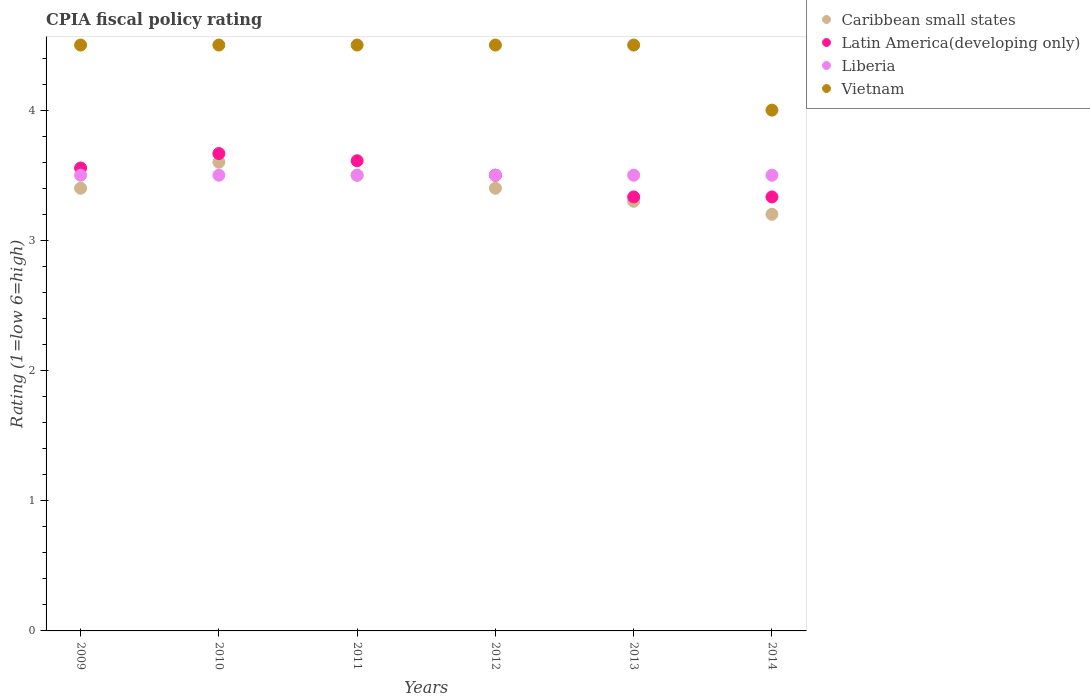What is the CPIA rating in Latin America(developing only) in 2011?
Provide a short and direct response. 3.61. Across all years, what is the maximum CPIA rating in Latin America(developing only)?
Make the answer very short. 3.67. Across all years, what is the minimum CPIA rating in Latin America(developing only)?
Ensure brevity in your answer.  3.33. What is the total CPIA rating in Latin America(developing only) in the graph?
Your answer should be compact. 21. What is the difference between the CPIA rating in Latin America(developing only) in 2009 and that in 2011?
Your response must be concise. -0.06. What is the difference between the CPIA rating in Caribbean small states in 2013 and the CPIA rating in Liberia in 2014?
Offer a very short reply. -0.2. What is the average CPIA rating in Vietnam per year?
Ensure brevity in your answer.  4.42. In the year 2012, what is the difference between the CPIA rating in Caribbean small states and CPIA rating in Liberia?
Make the answer very short. -0.1. In how many years, is the CPIA rating in Vietnam greater than 0.6000000000000001?
Offer a very short reply. 6. What is the difference between the highest and the second highest CPIA rating in Caribbean small states?
Make the answer very short. 0.1. In how many years, is the CPIA rating in Latin America(developing only) greater than the average CPIA rating in Latin America(developing only) taken over all years?
Offer a terse response. 4. Is the sum of the CPIA rating in Latin America(developing only) in 2011 and 2013 greater than the maximum CPIA rating in Liberia across all years?
Make the answer very short. Yes. Is it the case that in every year, the sum of the CPIA rating in Latin America(developing only) and CPIA rating in Liberia  is greater than the CPIA rating in Caribbean small states?
Offer a terse response. Yes. Is the CPIA rating in Caribbean small states strictly less than the CPIA rating in Liberia over the years?
Ensure brevity in your answer.  No. How many years are there in the graph?
Your answer should be very brief. 6. Are the values on the major ticks of Y-axis written in scientific E-notation?
Provide a succinct answer. No. Does the graph contain any zero values?
Keep it short and to the point. No. Does the graph contain grids?
Your answer should be compact. No. Where does the legend appear in the graph?
Make the answer very short. Top right. How many legend labels are there?
Your answer should be compact. 4. What is the title of the graph?
Your answer should be compact. CPIA fiscal policy rating. What is the Rating (1=low 6=high) of Latin America(developing only) in 2009?
Your answer should be very brief. 3.56. What is the Rating (1=low 6=high) in Latin America(developing only) in 2010?
Offer a very short reply. 3.67. What is the Rating (1=low 6=high) in Liberia in 2010?
Offer a very short reply. 3.5. What is the Rating (1=low 6=high) in Vietnam in 2010?
Your answer should be very brief. 4.5. What is the Rating (1=low 6=high) of Caribbean small states in 2011?
Provide a short and direct response. 3.5. What is the Rating (1=low 6=high) of Latin America(developing only) in 2011?
Make the answer very short. 3.61. What is the Rating (1=low 6=high) in Caribbean small states in 2012?
Provide a short and direct response. 3.4. What is the Rating (1=low 6=high) in Latin America(developing only) in 2012?
Provide a succinct answer. 3.5. What is the Rating (1=low 6=high) of Vietnam in 2012?
Offer a very short reply. 4.5. What is the Rating (1=low 6=high) of Caribbean small states in 2013?
Make the answer very short. 3.3. What is the Rating (1=low 6=high) in Latin America(developing only) in 2013?
Provide a succinct answer. 3.33. What is the Rating (1=low 6=high) of Vietnam in 2013?
Your answer should be compact. 4.5. What is the Rating (1=low 6=high) of Latin America(developing only) in 2014?
Keep it short and to the point. 3.33. What is the Rating (1=low 6=high) of Vietnam in 2014?
Ensure brevity in your answer.  4. Across all years, what is the maximum Rating (1=low 6=high) in Caribbean small states?
Offer a very short reply. 3.6. Across all years, what is the maximum Rating (1=low 6=high) of Latin America(developing only)?
Offer a terse response. 3.67. Across all years, what is the minimum Rating (1=low 6=high) of Caribbean small states?
Give a very brief answer. 3.2. Across all years, what is the minimum Rating (1=low 6=high) in Latin America(developing only)?
Provide a short and direct response. 3.33. What is the total Rating (1=low 6=high) in Caribbean small states in the graph?
Give a very brief answer. 20.4. What is the total Rating (1=low 6=high) in Latin America(developing only) in the graph?
Provide a short and direct response. 21. What is the total Rating (1=low 6=high) in Liberia in the graph?
Provide a short and direct response. 21. What is the total Rating (1=low 6=high) of Vietnam in the graph?
Make the answer very short. 26.5. What is the difference between the Rating (1=low 6=high) of Caribbean small states in 2009 and that in 2010?
Give a very brief answer. -0.2. What is the difference between the Rating (1=low 6=high) of Latin America(developing only) in 2009 and that in 2010?
Offer a very short reply. -0.11. What is the difference between the Rating (1=low 6=high) in Liberia in 2009 and that in 2010?
Your answer should be very brief. 0. What is the difference between the Rating (1=low 6=high) of Latin America(developing only) in 2009 and that in 2011?
Offer a terse response. -0.06. What is the difference between the Rating (1=low 6=high) in Latin America(developing only) in 2009 and that in 2012?
Your answer should be very brief. 0.06. What is the difference between the Rating (1=low 6=high) in Vietnam in 2009 and that in 2012?
Your response must be concise. 0. What is the difference between the Rating (1=low 6=high) of Caribbean small states in 2009 and that in 2013?
Offer a very short reply. 0.1. What is the difference between the Rating (1=low 6=high) in Latin America(developing only) in 2009 and that in 2013?
Offer a very short reply. 0.22. What is the difference between the Rating (1=low 6=high) in Caribbean small states in 2009 and that in 2014?
Offer a very short reply. 0.2. What is the difference between the Rating (1=low 6=high) in Latin America(developing only) in 2009 and that in 2014?
Keep it short and to the point. 0.22. What is the difference between the Rating (1=low 6=high) in Vietnam in 2009 and that in 2014?
Ensure brevity in your answer.  0.5. What is the difference between the Rating (1=low 6=high) in Latin America(developing only) in 2010 and that in 2011?
Your answer should be compact. 0.06. What is the difference between the Rating (1=low 6=high) in Liberia in 2010 and that in 2011?
Provide a short and direct response. 0. What is the difference between the Rating (1=low 6=high) of Caribbean small states in 2010 and that in 2012?
Keep it short and to the point. 0.2. What is the difference between the Rating (1=low 6=high) in Vietnam in 2010 and that in 2012?
Offer a terse response. 0. What is the difference between the Rating (1=low 6=high) in Latin America(developing only) in 2010 and that in 2013?
Provide a succinct answer. 0.33. What is the difference between the Rating (1=low 6=high) in Liberia in 2010 and that in 2013?
Give a very brief answer. 0. What is the difference between the Rating (1=low 6=high) in Vietnam in 2010 and that in 2013?
Give a very brief answer. 0. What is the difference between the Rating (1=low 6=high) in Liberia in 2011 and that in 2012?
Your response must be concise. 0. What is the difference between the Rating (1=low 6=high) in Vietnam in 2011 and that in 2012?
Provide a succinct answer. 0. What is the difference between the Rating (1=low 6=high) of Latin America(developing only) in 2011 and that in 2013?
Offer a terse response. 0.28. What is the difference between the Rating (1=low 6=high) in Liberia in 2011 and that in 2013?
Provide a short and direct response. 0. What is the difference between the Rating (1=low 6=high) in Vietnam in 2011 and that in 2013?
Provide a succinct answer. 0. What is the difference between the Rating (1=low 6=high) of Caribbean small states in 2011 and that in 2014?
Offer a very short reply. 0.3. What is the difference between the Rating (1=low 6=high) in Latin America(developing only) in 2011 and that in 2014?
Your answer should be very brief. 0.28. What is the difference between the Rating (1=low 6=high) of Latin America(developing only) in 2012 and that in 2013?
Ensure brevity in your answer.  0.17. What is the difference between the Rating (1=low 6=high) in Vietnam in 2012 and that in 2013?
Ensure brevity in your answer.  0. What is the difference between the Rating (1=low 6=high) of Caribbean small states in 2012 and that in 2014?
Your response must be concise. 0.2. What is the difference between the Rating (1=low 6=high) of Latin America(developing only) in 2012 and that in 2014?
Your answer should be very brief. 0.17. What is the difference between the Rating (1=low 6=high) in Liberia in 2012 and that in 2014?
Ensure brevity in your answer.  0. What is the difference between the Rating (1=low 6=high) in Vietnam in 2012 and that in 2014?
Give a very brief answer. 0.5. What is the difference between the Rating (1=low 6=high) of Vietnam in 2013 and that in 2014?
Provide a short and direct response. 0.5. What is the difference between the Rating (1=low 6=high) of Caribbean small states in 2009 and the Rating (1=low 6=high) of Latin America(developing only) in 2010?
Ensure brevity in your answer.  -0.27. What is the difference between the Rating (1=low 6=high) of Caribbean small states in 2009 and the Rating (1=low 6=high) of Liberia in 2010?
Offer a terse response. -0.1. What is the difference between the Rating (1=low 6=high) of Latin America(developing only) in 2009 and the Rating (1=low 6=high) of Liberia in 2010?
Give a very brief answer. 0.06. What is the difference between the Rating (1=low 6=high) in Latin America(developing only) in 2009 and the Rating (1=low 6=high) in Vietnam in 2010?
Your response must be concise. -0.94. What is the difference between the Rating (1=low 6=high) of Liberia in 2009 and the Rating (1=low 6=high) of Vietnam in 2010?
Provide a short and direct response. -1. What is the difference between the Rating (1=low 6=high) in Caribbean small states in 2009 and the Rating (1=low 6=high) in Latin America(developing only) in 2011?
Offer a terse response. -0.21. What is the difference between the Rating (1=low 6=high) in Caribbean small states in 2009 and the Rating (1=low 6=high) in Liberia in 2011?
Give a very brief answer. -0.1. What is the difference between the Rating (1=low 6=high) of Latin America(developing only) in 2009 and the Rating (1=low 6=high) of Liberia in 2011?
Keep it short and to the point. 0.06. What is the difference between the Rating (1=low 6=high) in Latin America(developing only) in 2009 and the Rating (1=low 6=high) in Vietnam in 2011?
Keep it short and to the point. -0.94. What is the difference between the Rating (1=low 6=high) in Liberia in 2009 and the Rating (1=low 6=high) in Vietnam in 2011?
Provide a succinct answer. -1. What is the difference between the Rating (1=low 6=high) in Caribbean small states in 2009 and the Rating (1=low 6=high) in Liberia in 2012?
Your answer should be compact. -0.1. What is the difference between the Rating (1=low 6=high) of Latin America(developing only) in 2009 and the Rating (1=low 6=high) of Liberia in 2012?
Provide a succinct answer. 0.06. What is the difference between the Rating (1=low 6=high) in Latin America(developing only) in 2009 and the Rating (1=low 6=high) in Vietnam in 2012?
Give a very brief answer. -0.94. What is the difference between the Rating (1=low 6=high) in Caribbean small states in 2009 and the Rating (1=low 6=high) in Latin America(developing only) in 2013?
Give a very brief answer. 0.07. What is the difference between the Rating (1=low 6=high) of Caribbean small states in 2009 and the Rating (1=low 6=high) of Liberia in 2013?
Your answer should be compact. -0.1. What is the difference between the Rating (1=low 6=high) of Caribbean small states in 2009 and the Rating (1=low 6=high) of Vietnam in 2013?
Provide a succinct answer. -1.1. What is the difference between the Rating (1=low 6=high) of Latin America(developing only) in 2009 and the Rating (1=low 6=high) of Liberia in 2013?
Provide a short and direct response. 0.06. What is the difference between the Rating (1=low 6=high) in Latin America(developing only) in 2009 and the Rating (1=low 6=high) in Vietnam in 2013?
Keep it short and to the point. -0.94. What is the difference between the Rating (1=low 6=high) in Liberia in 2009 and the Rating (1=low 6=high) in Vietnam in 2013?
Make the answer very short. -1. What is the difference between the Rating (1=low 6=high) in Caribbean small states in 2009 and the Rating (1=low 6=high) in Latin America(developing only) in 2014?
Your answer should be very brief. 0.07. What is the difference between the Rating (1=low 6=high) of Caribbean small states in 2009 and the Rating (1=low 6=high) of Vietnam in 2014?
Provide a succinct answer. -0.6. What is the difference between the Rating (1=low 6=high) in Latin America(developing only) in 2009 and the Rating (1=low 6=high) in Liberia in 2014?
Offer a very short reply. 0.06. What is the difference between the Rating (1=low 6=high) of Latin America(developing only) in 2009 and the Rating (1=low 6=high) of Vietnam in 2014?
Offer a terse response. -0.44. What is the difference between the Rating (1=low 6=high) of Caribbean small states in 2010 and the Rating (1=low 6=high) of Latin America(developing only) in 2011?
Your answer should be compact. -0.01. What is the difference between the Rating (1=low 6=high) in Caribbean small states in 2010 and the Rating (1=low 6=high) in Liberia in 2011?
Ensure brevity in your answer.  0.1. What is the difference between the Rating (1=low 6=high) in Caribbean small states in 2010 and the Rating (1=low 6=high) in Vietnam in 2011?
Keep it short and to the point. -0.9. What is the difference between the Rating (1=low 6=high) in Liberia in 2010 and the Rating (1=low 6=high) in Vietnam in 2011?
Offer a terse response. -1. What is the difference between the Rating (1=low 6=high) of Caribbean small states in 2010 and the Rating (1=low 6=high) of Latin America(developing only) in 2012?
Offer a very short reply. 0.1. What is the difference between the Rating (1=low 6=high) in Latin America(developing only) in 2010 and the Rating (1=low 6=high) in Liberia in 2012?
Your answer should be very brief. 0.17. What is the difference between the Rating (1=low 6=high) in Latin America(developing only) in 2010 and the Rating (1=low 6=high) in Vietnam in 2012?
Offer a very short reply. -0.83. What is the difference between the Rating (1=low 6=high) in Caribbean small states in 2010 and the Rating (1=low 6=high) in Latin America(developing only) in 2013?
Give a very brief answer. 0.27. What is the difference between the Rating (1=low 6=high) of Caribbean small states in 2010 and the Rating (1=low 6=high) of Liberia in 2013?
Make the answer very short. 0.1. What is the difference between the Rating (1=low 6=high) of Caribbean small states in 2010 and the Rating (1=low 6=high) of Latin America(developing only) in 2014?
Give a very brief answer. 0.27. What is the difference between the Rating (1=low 6=high) of Caribbean small states in 2010 and the Rating (1=low 6=high) of Liberia in 2014?
Your answer should be compact. 0.1. What is the difference between the Rating (1=low 6=high) of Caribbean small states in 2010 and the Rating (1=low 6=high) of Vietnam in 2014?
Keep it short and to the point. -0.4. What is the difference between the Rating (1=low 6=high) in Liberia in 2010 and the Rating (1=low 6=high) in Vietnam in 2014?
Offer a terse response. -0.5. What is the difference between the Rating (1=low 6=high) in Caribbean small states in 2011 and the Rating (1=low 6=high) in Latin America(developing only) in 2012?
Your answer should be very brief. 0. What is the difference between the Rating (1=low 6=high) in Caribbean small states in 2011 and the Rating (1=low 6=high) in Liberia in 2012?
Make the answer very short. 0. What is the difference between the Rating (1=low 6=high) of Latin America(developing only) in 2011 and the Rating (1=low 6=high) of Vietnam in 2012?
Your answer should be compact. -0.89. What is the difference between the Rating (1=low 6=high) in Liberia in 2011 and the Rating (1=low 6=high) in Vietnam in 2012?
Give a very brief answer. -1. What is the difference between the Rating (1=low 6=high) in Caribbean small states in 2011 and the Rating (1=low 6=high) in Liberia in 2013?
Offer a terse response. 0. What is the difference between the Rating (1=low 6=high) in Caribbean small states in 2011 and the Rating (1=low 6=high) in Vietnam in 2013?
Make the answer very short. -1. What is the difference between the Rating (1=low 6=high) of Latin America(developing only) in 2011 and the Rating (1=low 6=high) of Liberia in 2013?
Offer a very short reply. 0.11. What is the difference between the Rating (1=low 6=high) of Latin America(developing only) in 2011 and the Rating (1=low 6=high) of Vietnam in 2013?
Your answer should be compact. -0.89. What is the difference between the Rating (1=low 6=high) in Caribbean small states in 2011 and the Rating (1=low 6=high) in Vietnam in 2014?
Offer a terse response. -0.5. What is the difference between the Rating (1=low 6=high) of Latin America(developing only) in 2011 and the Rating (1=low 6=high) of Vietnam in 2014?
Your answer should be very brief. -0.39. What is the difference between the Rating (1=low 6=high) in Caribbean small states in 2012 and the Rating (1=low 6=high) in Latin America(developing only) in 2013?
Keep it short and to the point. 0.07. What is the difference between the Rating (1=low 6=high) of Caribbean small states in 2012 and the Rating (1=low 6=high) of Liberia in 2013?
Your answer should be very brief. -0.1. What is the difference between the Rating (1=low 6=high) in Caribbean small states in 2012 and the Rating (1=low 6=high) in Vietnam in 2013?
Ensure brevity in your answer.  -1.1. What is the difference between the Rating (1=low 6=high) in Caribbean small states in 2012 and the Rating (1=low 6=high) in Latin America(developing only) in 2014?
Make the answer very short. 0.07. What is the difference between the Rating (1=low 6=high) of Caribbean small states in 2012 and the Rating (1=low 6=high) of Vietnam in 2014?
Your answer should be compact. -0.6. What is the difference between the Rating (1=low 6=high) of Latin America(developing only) in 2012 and the Rating (1=low 6=high) of Liberia in 2014?
Provide a succinct answer. 0. What is the difference between the Rating (1=low 6=high) of Liberia in 2012 and the Rating (1=low 6=high) of Vietnam in 2014?
Your answer should be compact. -0.5. What is the difference between the Rating (1=low 6=high) of Caribbean small states in 2013 and the Rating (1=low 6=high) of Latin America(developing only) in 2014?
Keep it short and to the point. -0.03. What is the difference between the Rating (1=low 6=high) in Latin America(developing only) in 2013 and the Rating (1=low 6=high) in Liberia in 2014?
Your response must be concise. -0.17. What is the difference between the Rating (1=low 6=high) in Liberia in 2013 and the Rating (1=low 6=high) in Vietnam in 2014?
Keep it short and to the point. -0.5. What is the average Rating (1=low 6=high) of Caribbean small states per year?
Provide a short and direct response. 3.4. What is the average Rating (1=low 6=high) of Vietnam per year?
Your answer should be very brief. 4.42. In the year 2009, what is the difference between the Rating (1=low 6=high) in Caribbean small states and Rating (1=low 6=high) in Latin America(developing only)?
Your answer should be compact. -0.16. In the year 2009, what is the difference between the Rating (1=low 6=high) of Latin America(developing only) and Rating (1=low 6=high) of Liberia?
Your response must be concise. 0.06. In the year 2009, what is the difference between the Rating (1=low 6=high) in Latin America(developing only) and Rating (1=low 6=high) in Vietnam?
Give a very brief answer. -0.94. In the year 2009, what is the difference between the Rating (1=low 6=high) of Liberia and Rating (1=low 6=high) of Vietnam?
Ensure brevity in your answer.  -1. In the year 2010, what is the difference between the Rating (1=low 6=high) of Caribbean small states and Rating (1=low 6=high) of Latin America(developing only)?
Ensure brevity in your answer.  -0.07. In the year 2010, what is the difference between the Rating (1=low 6=high) in Caribbean small states and Rating (1=low 6=high) in Liberia?
Your answer should be compact. 0.1. In the year 2010, what is the difference between the Rating (1=low 6=high) of Latin America(developing only) and Rating (1=low 6=high) of Liberia?
Your answer should be compact. 0.17. In the year 2011, what is the difference between the Rating (1=low 6=high) of Caribbean small states and Rating (1=low 6=high) of Latin America(developing only)?
Provide a succinct answer. -0.11. In the year 2011, what is the difference between the Rating (1=low 6=high) of Caribbean small states and Rating (1=low 6=high) of Vietnam?
Your answer should be very brief. -1. In the year 2011, what is the difference between the Rating (1=low 6=high) of Latin America(developing only) and Rating (1=low 6=high) of Vietnam?
Ensure brevity in your answer.  -0.89. In the year 2012, what is the difference between the Rating (1=low 6=high) of Caribbean small states and Rating (1=low 6=high) of Latin America(developing only)?
Your answer should be very brief. -0.1. In the year 2012, what is the difference between the Rating (1=low 6=high) of Caribbean small states and Rating (1=low 6=high) of Vietnam?
Your answer should be compact. -1.1. In the year 2012, what is the difference between the Rating (1=low 6=high) of Latin America(developing only) and Rating (1=low 6=high) of Liberia?
Your answer should be very brief. 0. In the year 2013, what is the difference between the Rating (1=low 6=high) of Caribbean small states and Rating (1=low 6=high) of Latin America(developing only)?
Keep it short and to the point. -0.03. In the year 2013, what is the difference between the Rating (1=low 6=high) in Latin America(developing only) and Rating (1=low 6=high) in Vietnam?
Make the answer very short. -1.17. In the year 2014, what is the difference between the Rating (1=low 6=high) of Caribbean small states and Rating (1=low 6=high) of Latin America(developing only)?
Your answer should be very brief. -0.13. In the year 2014, what is the difference between the Rating (1=low 6=high) of Caribbean small states and Rating (1=low 6=high) of Liberia?
Give a very brief answer. -0.3. In the year 2014, what is the difference between the Rating (1=low 6=high) of Latin America(developing only) and Rating (1=low 6=high) of Liberia?
Provide a short and direct response. -0.17. In the year 2014, what is the difference between the Rating (1=low 6=high) in Liberia and Rating (1=low 6=high) in Vietnam?
Make the answer very short. -0.5. What is the ratio of the Rating (1=low 6=high) in Latin America(developing only) in 2009 to that in 2010?
Keep it short and to the point. 0.97. What is the ratio of the Rating (1=low 6=high) in Caribbean small states in 2009 to that in 2011?
Ensure brevity in your answer.  0.97. What is the ratio of the Rating (1=low 6=high) of Latin America(developing only) in 2009 to that in 2011?
Provide a succinct answer. 0.98. What is the ratio of the Rating (1=low 6=high) in Liberia in 2009 to that in 2011?
Provide a short and direct response. 1. What is the ratio of the Rating (1=low 6=high) of Latin America(developing only) in 2009 to that in 2012?
Offer a terse response. 1.02. What is the ratio of the Rating (1=low 6=high) of Liberia in 2009 to that in 2012?
Offer a terse response. 1. What is the ratio of the Rating (1=low 6=high) in Vietnam in 2009 to that in 2012?
Your answer should be very brief. 1. What is the ratio of the Rating (1=low 6=high) in Caribbean small states in 2009 to that in 2013?
Make the answer very short. 1.03. What is the ratio of the Rating (1=low 6=high) in Latin America(developing only) in 2009 to that in 2013?
Provide a succinct answer. 1.07. What is the ratio of the Rating (1=low 6=high) in Liberia in 2009 to that in 2013?
Offer a very short reply. 1. What is the ratio of the Rating (1=low 6=high) in Caribbean small states in 2009 to that in 2014?
Make the answer very short. 1.06. What is the ratio of the Rating (1=low 6=high) in Latin America(developing only) in 2009 to that in 2014?
Your response must be concise. 1.07. What is the ratio of the Rating (1=low 6=high) in Caribbean small states in 2010 to that in 2011?
Offer a terse response. 1.03. What is the ratio of the Rating (1=low 6=high) of Latin America(developing only) in 2010 to that in 2011?
Your response must be concise. 1.02. What is the ratio of the Rating (1=low 6=high) in Caribbean small states in 2010 to that in 2012?
Your response must be concise. 1.06. What is the ratio of the Rating (1=low 6=high) of Latin America(developing only) in 2010 to that in 2012?
Ensure brevity in your answer.  1.05. What is the ratio of the Rating (1=low 6=high) in Liberia in 2010 to that in 2012?
Offer a terse response. 1. What is the ratio of the Rating (1=low 6=high) in Vietnam in 2010 to that in 2012?
Provide a short and direct response. 1. What is the ratio of the Rating (1=low 6=high) of Caribbean small states in 2010 to that in 2013?
Ensure brevity in your answer.  1.09. What is the ratio of the Rating (1=low 6=high) in Vietnam in 2010 to that in 2013?
Give a very brief answer. 1. What is the ratio of the Rating (1=low 6=high) in Caribbean small states in 2010 to that in 2014?
Your response must be concise. 1.12. What is the ratio of the Rating (1=low 6=high) in Latin America(developing only) in 2010 to that in 2014?
Make the answer very short. 1.1. What is the ratio of the Rating (1=low 6=high) in Caribbean small states in 2011 to that in 2012?
Keep it short and to the point. 1.03. What is the ratio of the Rating (1=low 6=high) of Latin America(developing only) in 2011 to that in 2012?
Make the answer very short. 1.03. What is the ratio of the Rating (1=low 6=high) of Vietnam in 2011 to that in 2012?
Make the answer very short. 1. What is the ratio of the Rating (1=low 6=high) in Caribbean small states in 2011 to that in 2013?
Keep it short and to the point. 1.06. What is the ratio of the Rating (1=low 6=high) in Latin America(developing only) in 2011 to that in 2013?
Make the answer very short. 1.08. What is the ratio of the Rating (1=low 6=high) of Liberia in 2011 to that in 2013?
Offer a terse response. 1. What is the ratio of the Rating (1=low 6=high) in Caribbean small states in 2011 to that in 2014?
Make the answer very short. 1.09. What is the ratio of the Rating (1=low 6=high) of Latin America(developing only) in 2011 to that in 2014?
Your answer should be very brief. 1.08. What is the ratio of the Rating (1=low 6=high) of Caribbean small states in 2012 to that in 2013?
Ensure brevity in your answer.  1.03. What is the ratio of the Rating (1=low 6=high) in Latin America(developing only) in 2012 to that in 2013?
Offer a terse response. 1.05. What is the ratio of the Rating (1=low 6=high) in Liberia in 2012 to that in 2013?
Your answer should be compact. 1. What is the ratio of the Rating (1=low 6=high) of Vietnam in 2012 to that in 2013?
Your answer should be compact. 1. What is the ratio of the Rating (1=low 6=high) of Liberia in 2012 to that in 2014?
Provide a succinct answer. 1. What is the ratio of the Rating (1=low 6=high) of Caribbean small states in 2013 to that in 2014?
Offer a very short reply. 1.03. What is the ratio of the Rating (1=low 6=high) of Vietnam in 2013 to that in 2014?
Provide a succinct answer. 1.12. What is the difference between the highest and the second highest Rating (1=low 6=high) in Caribbean small states?
Your response must be concise. 0.1. What is the difference between the highest and the second highest Rating (1=low 6=high) of Latin America(developing only)?
Give a very brief answer. 0.06. What is the difference between the highest and the lowest Rating (1=low 6=high) in Latin America(developing only)?
Make the answer very short. 0.33. What is the difference between the highest and the lowest Rating (1=low 6=high) of Liberia?
Offer a terse response. 0. 